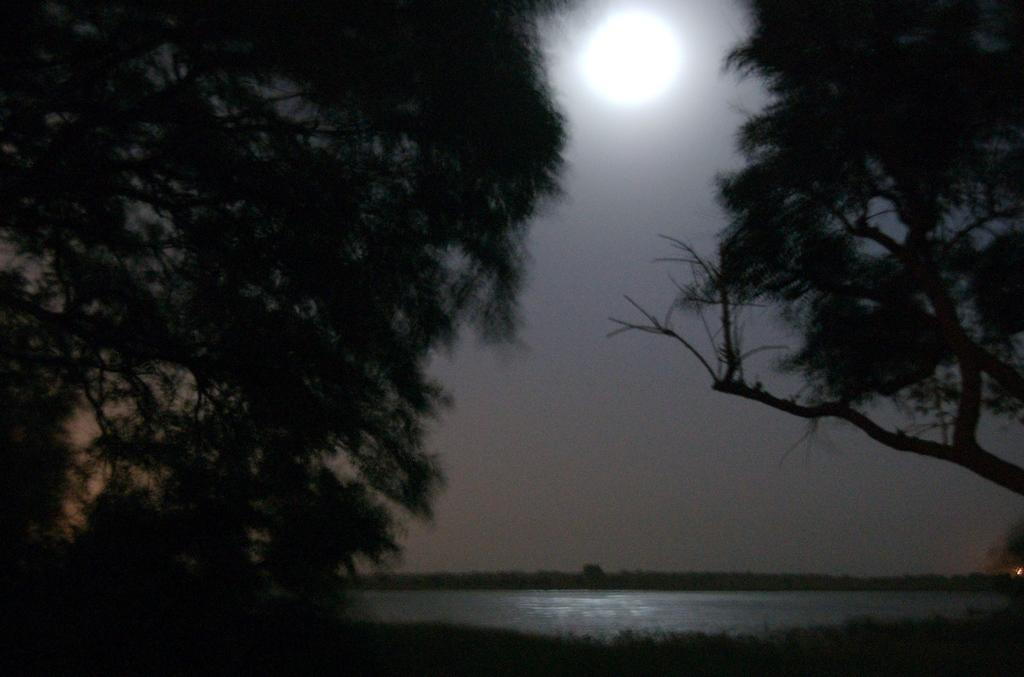Where was the picture taken? The picture was clicked outside the city. What can be seen in the foreground of the image? There is a water body in the foreground of the image. What is visible in the sky in the background of the image? There is a moon visible in the sky in the background of the image. What type of vegetation can be seen in the background of the image? There are trees visible in the background of the image. What type of rhythm does the hen in the image have? There is no hen present in the image, so it is not possible to determine its rhythm. 